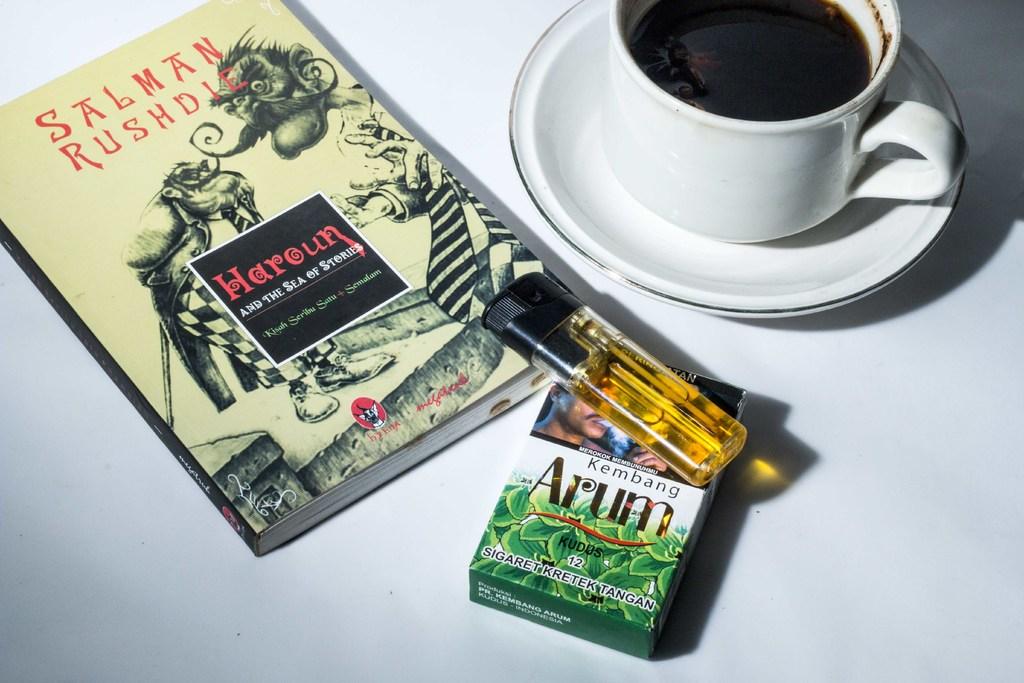What is the title of the book?
Give a very brief answer. Haroun. 